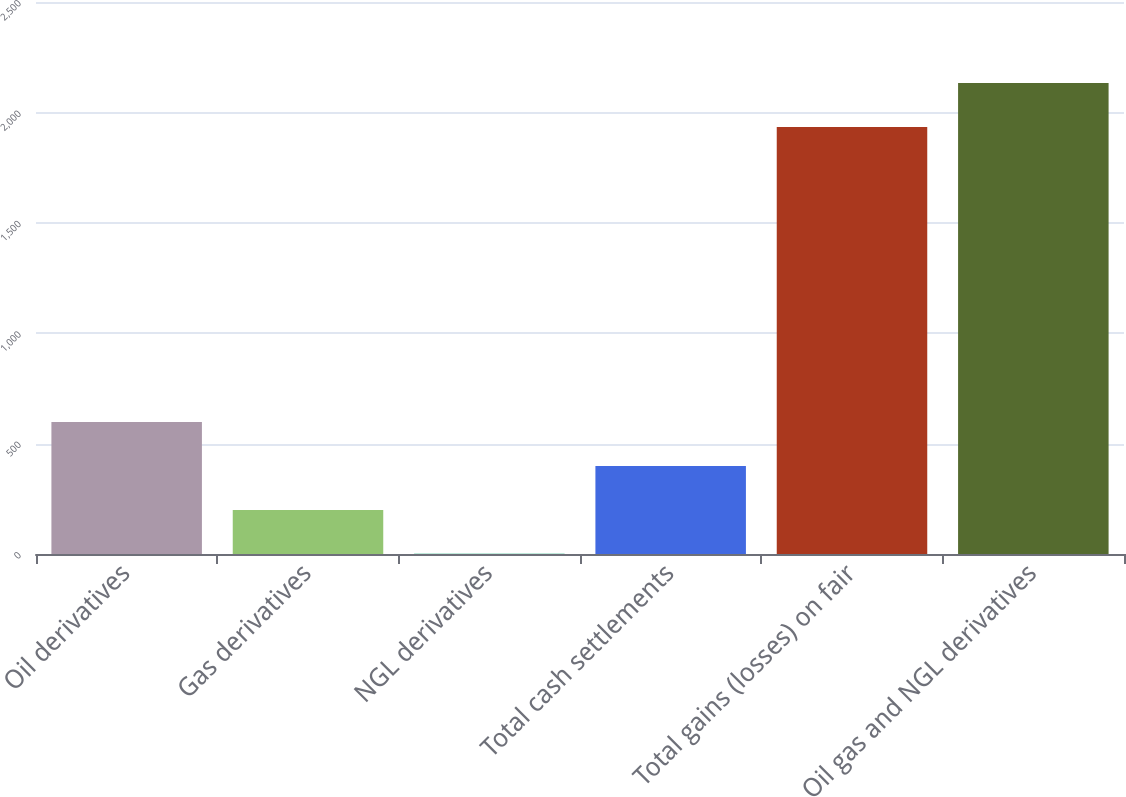Convert chart to OTSL. <chart><loc_0><loc_0><loc_500><loc_500><bar_chart><fcel>Oil derivatives<fcel>Gas derivatives<fcel>NGL derivatives<fcel>Total cash settlements<fcel>Total gains (losses) on fair<fcel>Oil gas and NGL derivatives<nl><fcel>597.4<fcel>199.8<fcel>1<fcel>398.6<fcel>1934<fcel>2132.8<nl></chart> 